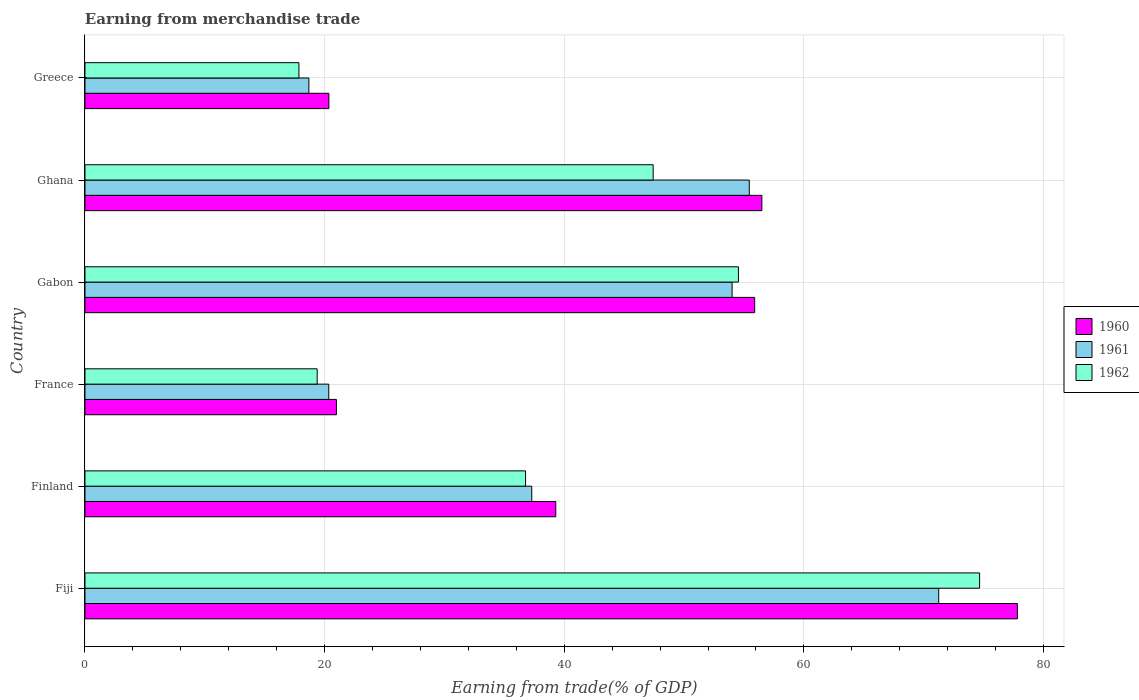Are the number of bars per tick equal to the number of legend labels?
Provide a short and direct response. Yes. Are the number of bars on each tick of the Y-axis equal?
Provide a succinct answer. Yes. How many bars are there on the 6th tick from the top?
Ensure brevity in your answer.  3. What is the label of the 3rd group of bars from the top?
Make the answer very short. Gabon. In how many cases, is the number of bars for a given country not equal to the number of legend labels?
Your answer should be very brief. 0. What is the earnings from trade in 1961 in France?
Keep it short and to the point. 20.35. Across all countries, what is the maximum earnings from trade in 1960?
Your answer should be very brief. 77.82. Across all countries, what is the minimum earnings from trade in 1961?
Make the answer very short. 18.69. In which country was the earnings from trade in 1962 maximum?
Your answer should be compact. Fiji. In which country was the earnings from trade in 1962 minimum?
Ensure brevity in your answer.  Greece. What is the total earnings from trade in 1960 in the graph?
Offer a terse response. 270.85. What is the difference between the earnings from trade in 1962 in France and that in Ghana?
Ensure brevity in your answer.  -28.04. What is the difference between the earnings from trade in 1960 in Greece and the earnings from trade in 1961 in Fiji?
Provide a short and direct response. -50.9. What is the average earnings from trade in 1960 per country?
Your answer should be compact. 45.14. What is the difference between the earnings from trade in 1962 and earnings from trade in 1960 in France?
Provide a short and direct response. -1.61. In how many countries, is the earnings from trade in 1962 greater than 52 %?
Give a very brief answer. 2. What is the ratio of the earnings from trade in 1962 in Fiji to that in Greece?
Offer a terse response. 4.18. What is the difference between the highest and the second highest earnings from trade in 1962?
Ensure brevity in your answer.  20.13. What is the difference between the highest and the lowest earnings from trade in 1961?
Make the answer very short. 52.56. In how many countries, is the earnings from trade in 1962 greater than the average earnings from trade in 1962 taken over all countries?
Ensure brevity in your answer.  3. Is the sum of the earnings from trade in 1960 in Fiji and France greater than the maximum earnings from trade in 1962 across all countries?
Your answer should be compact. Yes. Is it the case that in every country, the sum of the earnings from trade in 1962 and earnings from trade in 1961 is greater than the earnings from trade in 1960?
Offer a very short reply. Yes. How many bars are there?
Provide a short and direct response. 18. Are the values on the major ticks of X-axis written in scientific E-notation?
Ensure brevity in your answer.  No. Does the graph contain any zero values?
Your answer should be compact. No. Does the graph contain grids?
Ensure brevity in your answer.  Yes. Where does the legend appear in the graph?
Your answer should be very brief. Center right. What is the title of the graph?
Make the answer very short. Earning from merchandise trade. Does "1966" appear as one of the legend labels in the graph?
Give a very brief answer. No. What is the label or title of the X-axis?
Your response must be concise. Earning from trade(% of GDP). What is the Earning from trade(% of GDP) in 1960 in Fiji?
Provide a succinct answer. 77.82. What is the Earning from trade(% of GDP) of 1961 in Fiji?
Give a very brief answer. 71.25. What is the Earning from trade(% of GDP) in 1962 in Fiji?
Offer a terse response. 74.67. What is the Earning from trade(% of GDP) in 1960 in Finland?
Give a very brief answer. 39.29. What is the Earning from trade(% of GDP) in 1961 in Finland?
Provide a succinct answer. 37.29. What is the Earning from trade(% of GDP) in 1962 in Finland?
Ensure brevity in your answer.  36.77. What is the Earning from trade(% of GDP) of 1960 in France?
Make the answer very short. 20.99. What is the Earning from trade(% of GDP) in 1961 in France?
Provide a short and direct response. 20.35. What is the Earning from trade(% of GDP) in 1962 in France?
Offer a terse response. 19.38. What is the Earning from trade(% of GDP) in 1960 in Gabon?
Make the answer very short. 55.9. What is the Earning from trade(% of GDP) of 1961 in Gabon?
Your answer should be compact. 54.01. What is the Earning from trade(% of GDP) of 1962 in Gabon?
Keep it short and to the point. 54.54. What is the Earning from trade(% of GDP) in 1960 in Ghana?
Keep it short and to the point. 56.5. What is the Earning from trade(% of GDP) in 1961 in Ghana?
Keep it short and to the point. 55.44. What is the Earning from trade(% of GDP) in 1962 in Ghana?
Your answer should be compact. 47.42. What is the Earning from trade(% of GDP) in 1960 in Greece?
Your answer should be very brief. 20.36. What is the Earning from trade(% of GDP) in 1961 in Greece?
Provide a succinct answer. 18.69. What is the Earning from trade(% of GDP) in 1962 in Greece?
Your response must be concise. 17.86. Across all countries, what is the maximum Earning from trade(% of GDP) of 1960?
Keep it short and to the point. 77.82. Across all countries, what is the maximum Earning from trade(% of GDP) in 1961?
Your response must be concise. 71.25. Across all countries, what is the maximum Earning from trade(% of GDP) in 1962?
Offer a very short reply. 74.67. Across all countries, what is the minimum Earning from trade(% of GDP) of 1960?
Keep it short and to the point. 20.36. Across all countries, what is the minimum Earning from trade(% of GDP) of 1961?
Give a very brief answer. 18.69. Across all countries, what is the minimum Earning from trade(% of GDP) in 1962?
Your answer should be very brief. 17.86. What is the total Earning from trade(% of GDP) in 1960 in the graph?
Provide a succinct answer. 270.85. What is the total Earning from trade(% of GDP) of 1961 in the graph?
Provide a succinct answer. 257.03. What is the total Earning from trade(% of GDP) of 1962 in the graph?
Your response must be concise. 250.64. What is the difference between the Earning from trade(% of GDP) in 1960 in Fiji and that in Finland?
Your response must be concise. 38.52. What is the difference between the Earning from trade(% of GDP) of 1961 in Fiji and that in Finland?
Give a very brief answer. 33.96. What is the difference between the Earning from trade(% of GDP) of 1962 in Fiji and that in Finland?
Offer a terse response. 37.9. What is the difference between the Earning from trade(% of GDP) of 1960 in Fiji and that in France?
Offer a very short reply. 56.83. What is the difference between the Earning from trade(% of GDP) of 1961 in Fiji and that in France?
Provide a short and direct response. 50.91. What is the difference between the Earning from trade(% of GDP) of 1962 in Fiji and that in France?
Your answer should be very brief. 55.29. What is the difference between the Earning from trade(% of GDP) of 1960 in Fiji and that in Gabon?
Your answer should be very brief. 21.92. What is the difference between the Earning from trade(% of GDP) of 1961 in Fiji and that in Gabon?
Ensure brevity in your answer.  17.24. What is the difference between the Earning from trade(% of GDP) of 1962 in Fiji and that in Gabon?
Your answer should be compact. 20.13. What is the difference between the Earning from trade(% of GDP) of 1960 in Fiji and that in Ghana?
Provide a succinct answer. 21.32. What is the difference between the Earning from trade(% of GDP) of 1961 in Fiji and that in Ghana?
Your response must be concise. 15.81. What is the difference between the Earning from trade(% of GDP) in 1962 in Fiji and that in Ghana?
Provide a short and direct response. 27.25. What is the difference between the Earning from trade(% of GDP) of 1960 in Fiji and that in Greece?
Give a very brief answer. 57.46. What is the difference between the Earning from trade(% of GDP) in 1961 in Fiji and that in Greece?
Offer a terse response. 52.56. What is the difference between the Earning from trade(% of GDP) of 1962 in Fiji and that in Greece?
Your response must be concise. 56.81. What is the difference between the Earning from trade(% of GDP) of 1960 in Finland and that in France?
Your response must be concise. 18.31. What is the difference between the Earning from trade(% of GDP) of 1961 in Finland and that in France?
Provide a short and direct response. 16.94. What is the difference between the Earning from trade(% of GDP) in 1962 in Finland and that in France?
Ensure brevity in your answer.  17.39. What is the difference between the Earning from trade(% of GDP) of 1960 in Finland and that in Gabon?
Make the answer very short. -16.6. What is the difference between the Earning from trade(% of GDP) of 1961 in Finland and that in Gabon?
Ensure brevity in your answer.  -16.72. What is the difference between the Earning from trade(% of GDP) of 1962 in Finland and that in Gabon?
Offer a terse response. -17.77. What is the difference between the Earning from trade(% of GDP) in 1960 in Finland and that in Ghana?
Provide a short and direct response. -17.2. What is the difference between the Earning from trade(% of GDP) in 1961 in Finland and that in Ghana?
Your answer should be very brief. -18.16. What is the difference between the Earning from trade(% of GDP) in 1962 in Finland and that in Ghana?
Keep it short and to the point. -10.65. What is the difference between the Earning from trade(% of GDP) of 1960 in Finland and that in Greece?
Your response must be concise. 18.94. What is the difference between the Earning from trade(% of GDP) in 1961 in Finland and that in Greece?
Offer a terse response. 18.6. What is the difference between the Earning from trade(% of GDP) in 1962 in Finland and that in Greece?
Provide a short and direct response. 18.92. What is the difference between the Earning from trade(% of GDP) of 1960 in France and that in Gabon?
Give a very brief answer. -34.91. What is the difference between the Earning from trade(% of GDP) of 1961 in France and that in Gabon?
Ensure brevity in your answer.  -33.66. What is the difference between the Earning from trade(% of GDP) in 1962 in France and that in Gabon?
Keep it short and to the point. -35.16. What is the difference between the Earning from trade(% of GDP) of 1960 in France and that in Ghana?
Keep it short and to the point. -35.51. What is the difference between the Earning from trade(% of GDP) of 1961 in France and that in Ghana?
Your answer should be very brief. -35.1. What is the difference between the Earning from trade(% of GDP) in 1962 in France and that in Ghana?
Your answer should be very brief. -28.04. What is the difference between the Earning from trade(% of GDP) in 1960 in France and that in Greece?
Provide a succinct answer. 0.63. What is the difference between the Earning from trade(% of GDP) of 1961 in France and that in Greece?
Keep it short and to the point. 1.66. What is the difference between the Earning from trade(% of GDP) of 1962 in France and that in Greece?
Ensure brevity in your answer.  1.52. What is the difference between the Earning from trade(% of GDP) of 1960 in Gabon and that in Ghana?
Offer a very short reply. -0.6. What is the difference between the Earning from trade(% of GDP) in 1961 in Gabon and that in Ghana?
Make the answer very short. -1.44. What is the difference between the Earning from trade(% of GDP) in 1962 in Gabon and that in Ghana?
Provide a short and direct response. 7.12. What is the difference between the Earning from trade(% of GDP) in 1960 in Gabon and that in Greece?
Keep it short and to the point. 35.54. What is the difference between the Earning from trade(% of GDP) of 1961 in Gabon and that in Greece?
Make the answer very short. 35.32. What is the difference between the Earning from trade(% of GDP) of 1962 in Gabon and that in Greece?
Offer a terse response. 36.68. What is the difference between the Earning from trade(% of GDP) in 1960 in Ghana and that in Greece?
Give a very brief answer. 36.14. What is the difference between the Earning from trade(% of GDP) of 1961 in Ghana and that in Greece?
Give a very brief answer. 36.76. What is the difference between the Earning from trade(% of GDP) of 1962 in Ghana and that in Greece?
Ensure brevity in your answer.  29.57. What is the difference between the Earning from trade(% of GDP) of 1960 in Fiji and the Earning from trade(% of GDP) of 1961 in Finland?
Make the answer very short. 40.53. What is the difference between the Earning from trade(% of GDP) in 1960 in Fiji and the Earning from trade(% of GDP) in 1962 in Finland?
Offer a terse response. 41.05. What is the difference between the Earning from trade(% of GDP) in 1961 in Fiji and the Earning from trade(% of GDP) in 1962 in Finland?
Your response must be concise. 34.48. What is the difference between the Earning from trade(% of GDP) of 1960 in Fiji and the Earning from trade(% of GDP) of 1961 in France?
Offer a very short reply. 57.47. What is the difference between the Earning from trade(% of GDP) of 1960 in Fiji and the Earning from trade(% of GDP) of 1962 in France?
Give a very brief answer. 58.44. What is the difference between the Earning from trade(% of GDP) in 1961 in Fiji and the Earning from trade(% of GDP) in 1962 in France?
Provide a succinct answer. 51.87. What is the difference between the Earning from trade(% of GDP) in 1960 in Fiji and the Earning from trade(% of GDP) in 1961 in Gabon?
Your answer should be compact. 23.81. What is the difference between the Earning from trade(% of GDP) of 1960 in Fiji and the Earning from trade(% of GDP) of 1962 in Gabon?
Offer a terse response. 23.28. What is the difference between the Earning from trade(% of GDP) in 1961 in Fiji and the Earning from trade(% of GDP) in 1962 in Gabon?
Provide a succinct answer. 16.71. What is the difference between the Earning from trade(% of GDP) of 1960 in Fiji and the Earning from trade(% of GDP) of 1961 in Ghana?
Ensure brevity in your answer.  22.38. What is the difference between the Earning from trade(% of GDP) in 1960 in Fiji and the Earning from trade(% of GDP) in 1962 in Ghana?
Provide a succinct answer. 30.4. What is the difference between the Earning from trade(% of GDP) in 1961 in Fiji and the Earning from trade(% of GDP) in 1962 in Ghana?
Your response must be concise. 23.83. What is the difference between the Earning from trade(% of GDP) of 1960 in Fiji and the Earning from trade(% of GDP) of 1961 in Greece?
Your response must be concise. 59.13. What is the difference between the Earning from trade(% of GDP) in 1960 in Fiji and the Earning from trade(% of GDP) in 1962 in Greece?
Your answer should be very brief. 59.96. What is the difference between the Earning from trade(% of GDP) of 1961 in Fiji and the Earning from trade(% of GDP) of 1962 in Greece?
Your response must be concise. 53.4. What is the difference between the Earning from trade(% of GDP) in 1960 in Finland and the Earning from trade(% of GDP) in 1961 in France?
Offer a terse response. 18.95. What is the difference between the Earning from trade(% of GDP) of 1960 in Finland and the Earning from trade(% of GDP) of 1962 in France?
Offer a very short reply. 19.91. What is the difference between the Earning from trade(% of GDP) in 1961 in Finland and the Earning from trade(% of GDP) in 1962 in France?
Offer a terse response. 17.91. What is the difference between the Earning from trade(% of GDP) of 1960 in Finland and the Earning from trade(% of GDP) of 1961 in Gabon?
Provide a short and direct response. -14.71. What is the difference between the Earning from trade(% of GDP) in 1960 in Finland and the Earning from trade(% of GDP) in 1962 in Gabon?
Your answer should be very brief. -15.24. What is the difference between the Earning from trade(% of GDP) in 1961 in Finland and the Earning from trade(% of GDP) in 1962 in Gabon?
Offer a very short reply. -17.25. What is the difference between the Earning from trade(% of GDP) of 1960 in Finland and the Earning from trade(% of GDP) of 1961 in Ghana?
Ensure brevity in your answer.  -16.15. What is the difference between the Earning from trade(% of GDP) in 1960 in Finland and the Earning from trade(% of GDP) in 1962 in Ghana?
Make the answer very short. -8.13. What is the difference between the Earning from trade(% of GDP) of 1961 in Finland and the Earning from trade(% of GDP) of 1962 in Ghana?
Provide a short and direct response. -10.13. What is the difference between the Earning from trade(% of GDP) of 1960 in Finland and the Earning from trade(% of GDP) of 1961 in Greece?
Offer a very short reply. 20.61. What is the difference between the Earning from trade(% of GDP) of 1960 in Finland and the Earning from trade(% of GDP) of 1962 in Greece?
Your answer should be compact. 21.44. What is the difference between the Earning from trade(% of GDP) in 1961 in Finland and the Earning from trade(% of GDP) in 1962 in Greece?
Provide a succinct answer. 19.43. What is the difference between the Earning from trade(% of GDP) of 1960 in France and the Earning from trade(% of GDP) of 1961 in Gabon?
Provide a succinct answer. -33.02. What is the difference between the Earning from trade(% of GDP) of 1960 in France and the Earning from trade(% of GDP) of 1962 in Gabon?
Provide a succinct answer. -33.55. What is the difference between the Earning from trade(% of GDP) of 1961 in France and the Earning from trade(% of GDP) of 1962 in Gabon?
Keep it short and to the point. -34.19. What is the difference between the Earning from trade(% of GDP) of 1960 in France and the Earning from trade(% of GDP) of 1961 in Ghana?
Give a very brief answer. -34.46. What is the difference between the Earning from trade(% of GDP) in 1960 in France and the Earning from trade(% of GDP) in 1962 in Ghana?
Your response must be concise. -26.43. What is the difference between the Earning from trade(% of GDP) in 1961 in France and the Earning from trade(% of GDP) in 1962 in Ghana?
Make the answer very short. -27.07. What is the difference between the Earning from trade(% of GDP) of 1960 in France and the Earning from trade(% of GDP) of 1961 in Greece?
Offer a very short reply. 2.3. What is the difference between the Earning from trade(% of GDP) in 1960 in France and the Earning from trade(% of GDP) in 1962 in Greece?
Give a very brief answer. 3.13. What is the difference between the Earning from trade(% of GDP) of 1961 in France and the Earning from trade(% of GDP) of 1962 in Greece?
Your response must be concise. 2.49. What is the difference between the Earning from trade(% of GDP) of 1960 in Gabon and the Earning from trade(% of GDP) of 1961 in Ghana?
Make the answer very short. 0.45. What is the difference between the Earning from trade(% of GDP) in 1960 in Gabon and the Earning from trade(% of GDP) in 1962 in Ghana?
Make the answer very short. 8.47. What is the difference between the Earning from trade(% of GDP) in 1961 in Gabon and the Earning from trade(% of GDP) in 1962 in Ghana?
Provide a short and direct response. 6.59. What is the difference between the Earning from trade(% of GDP) in 1960 in Gabon and the Earning from trade(% of GDP) in 1961 in Greece?
Provide a succinct answer. 37.21. What is the difference between the Earning from trade(% of GDP) of 1960 in Gabon and the Earning from trade(% of GDP) of 1962 in Greece?
Offer a terse response. 38.04. What is the difference between the Earning from trade(% of GDP) in 1961 in Gabon and the Earning from trade(% of GDP) in 1962 in Greece?
Give a very brief answer. 36.15. What is the difference between the Earning from trade(% of GDP) in 1960 in Ghana and the Earning from trade(% of GDP) in 1961 in Greece?
Your answer should be very brief. 37.81. What is the difference between the Earning from trade(% of GDP) in 1960 in Ghana and the Earning from trade(% of GDP) in 1962 in Greece?
Provide a succinct answer. 38.64. What is the difference between the Earning from trade(% of GDP) of 1961 in Ghana and the Earning from trade(% of GDP) of 1962 in Greece?
Offer a terse response. 37.59. What is the average Earning from trade(% of GDP) in 1960 per country?
Your response must be concise. 45.14. What is the average Earning from trade(% of GDP) of 1961 per country?
Your answer should be compact. 42.84. What is the average Earning from trade(% of GDP) in 1962 per country?
Provide a succinct answer. 41.77. What is the difference between the Earning from trade(% of GDP) of 1960 and Earning from trade(% of GDP) of 1961 in Fiji?
Make the answer very short. 6.57. What is the difference between the Earning from trade(% of GDP) in 1960 and Earning from trade(% of GDP) in 1962 in Fiji?
Provide a short and direct response. 3.15. What is the difference between the Earning from trade(% of GDP) in 1961 and Earning from trade(% of GDP) in 1962 in Fiji?
Provide a short and direct response. -3.42. What is the difference between the Earning from trade(% of GDP) of 1960 and Earning from trade(% of GDP) of 1961 in Finland?
Your response must be concise. 2.01. What is the difference between the Earning from trade(% of GDP) of 1960 and Earning from trade(% of GDP) of 1962 in Finland?
Make the answer very short. 2.52. What is the difference between the Earning from trade(% of GDP) in 1961 and Earning from trade(% of GDP) in 1962 in Finland?
Ensure brevity in your answer.  0.52. What is the difference between the Earning from trade(% of GDP) in 1960 and Earning from trade(% of GDP) in 1961 in France?
Your answer should be compact. 0.64. What is the difference between the Earning from trade(% of GDP) of 1960 and Earning from trade(% of GDP) of 1962 in France?
Your answer should be very brief. 1.61. What is the difference between the Earning from trade(% of GDP) in 1961 and Earning from trade(% of GDP) in 1962 in France?
Give a very brief answer. 0.97. What is the difference between the Earning from trade(% of GDP) in 1960 and Earning from trade(% of GDP) in 1961 in Gabon?
Ensure brevity in your answer.  1.89. What is the difference between the Earning from trade(% of GDP) of 1960 and Earning from trade(% of GDP) of 1962 in Gabon?
Ensure brevity in your answer.  1.36. What is the difference between the Earning from trade(% of GDP) of 1961 and Earning from trade(% of GDP) of 1962 in Gabon?
Keep it short and to the point. -0.53. What is the difference between the Earning from trade(% of GDP) in 1960 and Earning from trade(% of GDP) in 1961 in Ghana?
Your response must be concise. 1.05. What is the difference between the Earning from trade(% of GDP) in 1960 and Earning from trade(% of GDP) in 1962 in Ghana?
Keep it short and to the point. 9.07. What is the difference between the Earning from trade(% of GDP) in 1961 and Earning from trade(% of GDP) in 1962 in Ghana?
Provide a short and direct response. 8.02. What is the difference between the Earning from trade(% of GDP) of 1960 and Earning from trade(% of GDP) of 1961 in Greece?
Provide a succinct answer. 1.67. What is the difference between the Earning from trade(% of GDP) of 1960 and Earning from trade(% of GDP) of 1962 in Greece?
Your answer should be very brief. 2.5. What is the difference between the Earning from trade(% of GDP) of 1961 and Earning from trade(% of GDP) of 1962 in Greece?
Provide a short and direct response. 0.83. What is the ratio of the Earning from trade(% of GDP) of 1960 in Fiji to that in Finland?
Make the answer very short. 1.98. What is the ratio of the Earning from trade(% of GDP) of 1961 in Fiji to that in Finland?
Keep it short and to the point. 1.91. What is the ratio of the Earning from trade(% of GDP) of 1962 in Fiji to that in Finland?
Your answer should be very brief. 2.03. What is the ratio of the Earning from trade(% of GDP) in 1960 in Fiji to that in France?
Keep it short and to the point. 3.71. What is the ratio of the Earning from trade(% of GDP) of 1961 in Fiji to that in France?
Ensure brevity in your answer.  3.5. What is the ratio of the Earning from trade(% of GDP) of 1962 in Fiji to that in France?
Ensure brevity in your answer.  3.85. What is the ratio of the Earning from trade(% of GDP) in 1960 in Fiji to that in Gabon?
Make the answer very short. 1.39. What is the ratio of the Earning from trade(% of GDP) of 1961 in Fiji to that in Gabon?
Offer a terse response. 1.32. What is the ratio of the Earning from trade(% of GDP) of 1962 in Fiji to that in Gabon?
Give a very brief answer. 1.37. What is the ratio of the Earning from trade(% of GDP) of 1960 in Fiji to that in Ghana?
Provide a short and direct response. 1.38. What is the ratio of the Earning from trade(% of GDP) in 1961 in Fiji to that in Ghana?
Make the answer very short. 1.29. What is the ratio of the Earning from trade(% of GDP) in 1962 in Fiji to that in Ghana?
Your answer should be compact. 1.57. What is the ratio of the Earning from trade(% of GDP) of 1960 in Fiji to that in Greece?
Offer a very short reply. 3.82. What is the ratio of the Earning from trade(% of GDP) of 1961 in Fiji to that in Greece?
Your answer should be very brief. 3.81. What is the ratio of the Earning from trade(% of GDP) in 1962 in Fiji to that in Greece?
Give a very brief answer. 4.18. What is the ratio of the Earning from trade(% of GDP) of 1960 in Finland to that in France?
Offer a very short reply. 1.87. What is the ratio of the Earning from trade(% of GDP) of 1961 in Finland to that in France?
Ensure brevity in your answer.  1.83. What is the ratio of the Earning from trade(% of GDP) in 1962 in Finland to that in France?
Your response must be concise. 1.9. What is the ratio of the Earning from trade(% of GDP) of 1960 in Finland to that in Gabon?
Provide a succinct answer. 0.7. What is the ratio of the Earning from trade(% of GDP) in 1961 in Finland to that in Gabon?
Keep it short and to the point. 0.69. What is the ratio of the Earning from trade(% of GDP) in 1962 in Finland to that in Gabon?
Make the answer very short. 0.67. What is the ratio of the Earning from trade(% of GDP) of 1960 in Finland to that in Ghana?
Give a very brief answer. 0.7. What is the ratio of the Earning from trade(% of GDP) in 1961 in Finland to that in Ghana?
Ensure brevity in your answer.  0.67. What is the ratio of the Earning from trade(% of GDP) in 1962 in Finland to that in Ghana?
Your response must be concise. 0.78. What is the ratio of the Earning from trade(% of GDP) of 1960 in Finland to that in Greece?
Keep it short and to the point. 1.93. What is the ratio of the Earning from trade(% of GDP) in 1961 in Finland to that in Greece?
Your answer should be compact. 2. What is the ratio of the Earning from trade(% of GDP) of 1962 in Finland to that in Greece?
Your response must be concise. 2.06. What is the ratio of the Earning from trade(% of GDP) of 1960 in France to that in Gabon?
Make the answer very short. 0.38. What is the ratio of the Earning from trade(% of GDP) of 1961 in France to that in Gabon?
Keep it short and to the point. 0.38. What is the ratio of the Earning from trade(% of GDP) in 1962 in France to that in Gabon?
Your response must be concise. 0.36. What is the ratio of the Earning from trade(% of GDP) of 1960 in France to that in Ghana?
Give a very brief answer. 0.37. What is the ratio of the Earning from trade(% of GDP) of 1961 in France to that in Ghana?
Make the answer very short. 0.37. What is the ratio of the Earning from trade(% of GDP) in 1962 in France to that in Ghana?
Your response must be concise. 0.41. What is the ratio of the Earning from trade(% of GDP) of 1960 in France to that in Greece?
Give a very brief answer. 1.03. What is the ratio of the Earning from trade(% of GDP) in 1961 in France to that in Greece?
Your answer should be compact. 1.09. What is the ratio of the Earning from trade(% of GDP) in 1962 in France to that in Greece?
Keep it short and to the point. 1.09. What is the ratio of the Earning from trade(% of GDP) of 1960 in Gabon to that in Ghana?
Keep it short and to the point. 0.99. What is the ratio of the Earning from trade(% of GDP) in 1961 in Gabon to that in Ghana?
Your response must be concise. 0.97. What is the ratio of the Earning from trade(% of GDP) of 1962 in Gabon to that in Ghana?
Offer a terse response. 1.15. What is the ratio of the Earning from trade(% of GDP) of 1960 in Gabon to that in Greece?
Offer a very short reply. 2.75. What is the ratio of the Earning from trade(% of GDP) in 1961 in Gabon to that in Greece?
Your response must be concise. 2.89. What is the ratio of the Earning from trade(% of GDP) of 1962 in Gabon to that in Greece?
Your response must be concise. 3.05. What is the ratio of the Earning from trade(% of GDP) of 1960 in Ghana to that in Greece?
Give a very brief answer. 2.78. What is the ratio of the Earning from trade(% of GDP) in 1961 in Ghana to that in Greece?
Give a very brief answer. 2.97. What is the ratio of the Earning from trade(% of GDP) in 1962 in Ghana to that in Greece?
Offer a terse response. 2.66. What is the difference between the highest and the second highest Earning from trade(% of GDP) in 1960?
Make the answer very short. 21.32. What is the difference between the highest and the second highest Earning from trade(% of GDP) of 1961?
Offer a very short reply. 15.81. What is the difference between the highest and the second highest Earning from trade(% of GDP) in 1962?
Your answer should be compact. 20.13. What is the difference between the highest and the lowest Earning from trade(% of GDP) in 1960?
Provide a succinct answer. 57.46. What is the difference between the highest and the lowest Earning from trade(% of GDP) of 1961?
Give a very brief answer. 52.56. What is the difference between the highest and the lowest Earning from trade(% of GDP) in 1962?
Offer a very short reply. 56.81. 